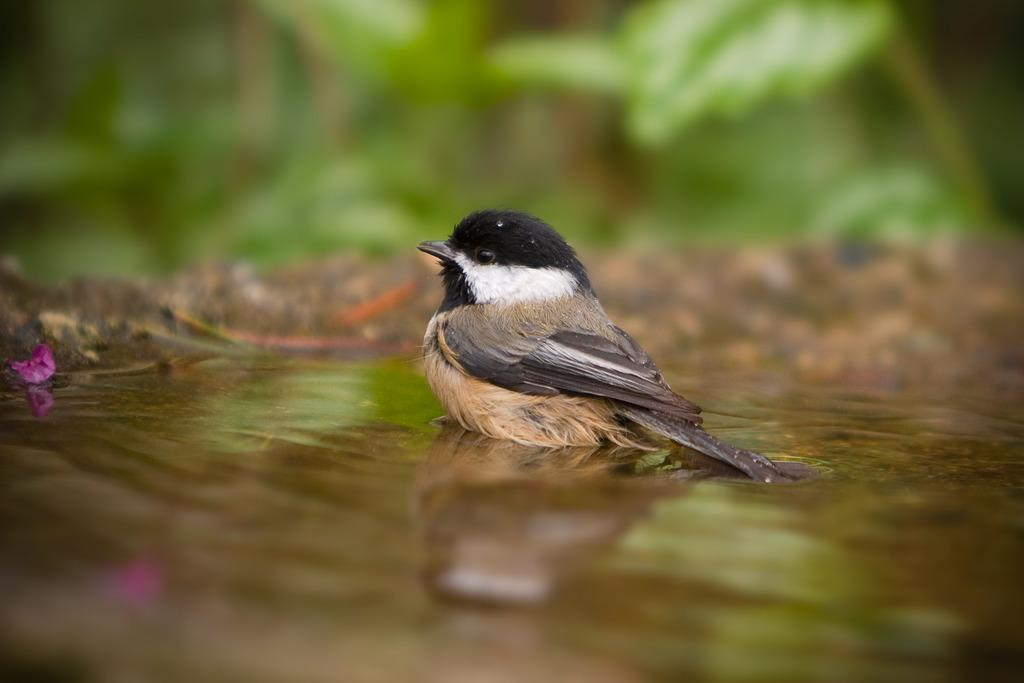What is located in the water in the image? There is a bird in the water in the image. Can you describe the background of the image? The background of the image is blurred. What type of zinc can be seen in the image? There is no zinc present in the image. How many trains are visible in the image? There are no trains visible in the image. 